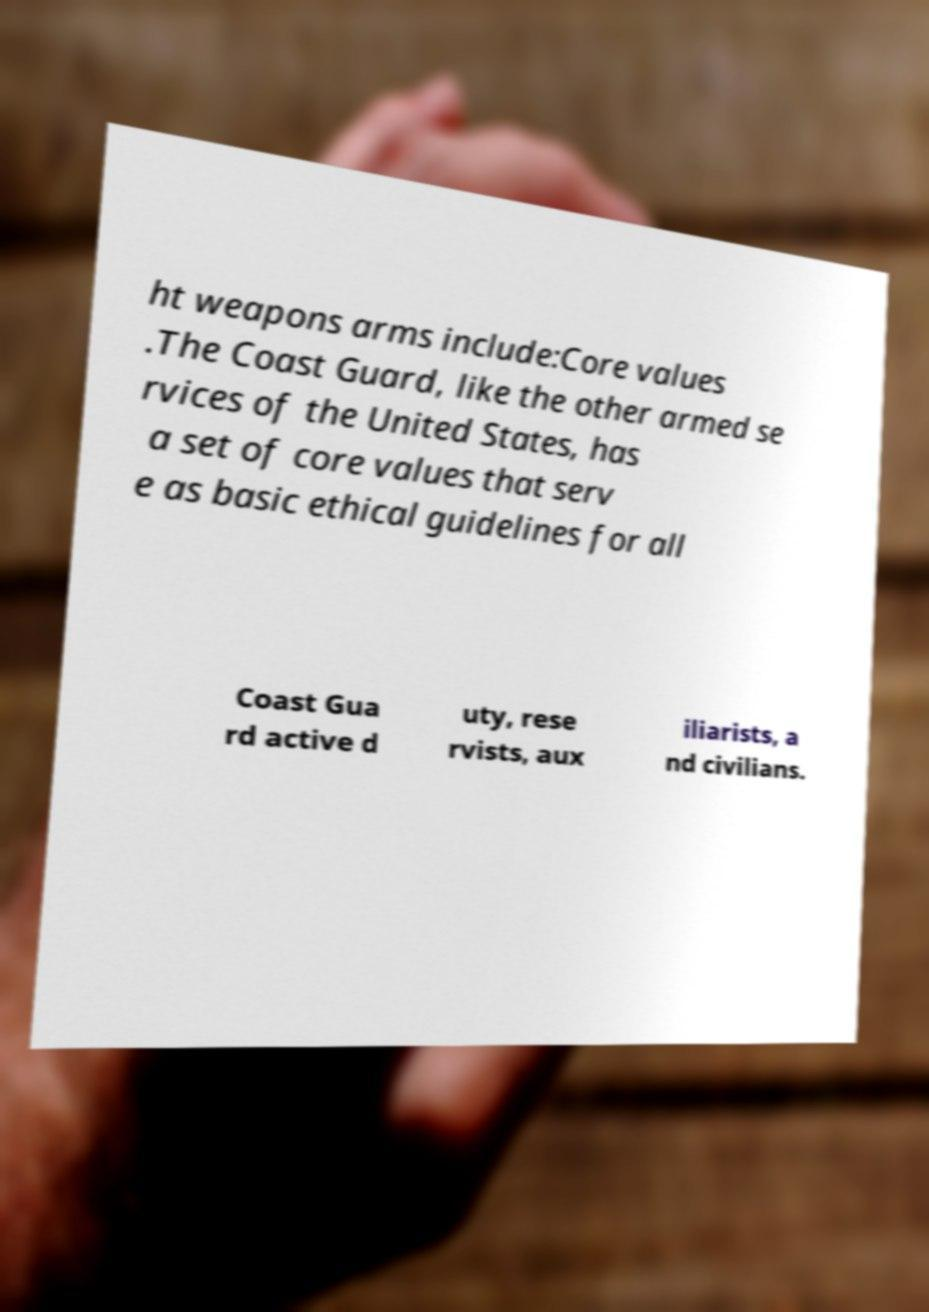There's text embedded in this image that I need extracted. Can you transcribe it verbatim? ht weapons arms include:Core values .The Coast Guard, like the other armed se rvices of the United States, has a set of core values that serv e as basic ethical guidelines for all Coast Gua rd active d uty, rese rvists, aux iliarists, a nd civilians. 